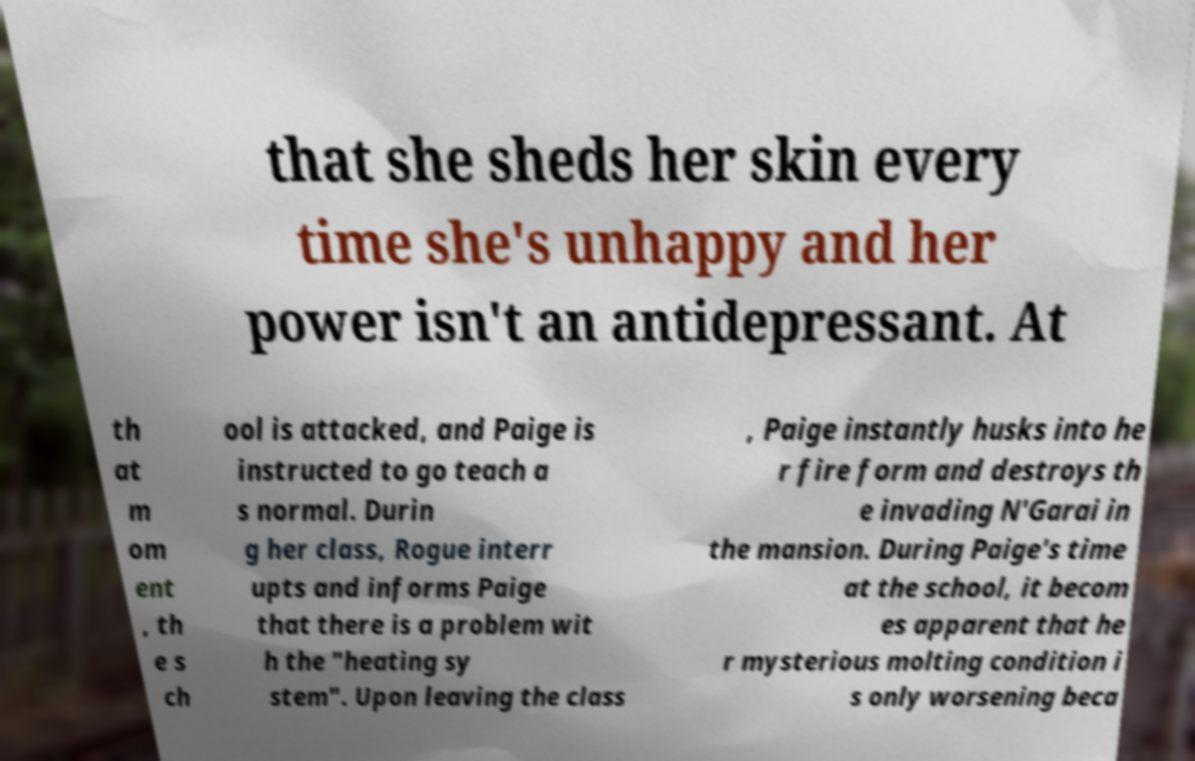Could you assist in decoding the text presented in this image and type it out clearly? that she sheds her skin every time she's unhappy and her power isn't an antidepressant. At th at m om ent , th e s ch ool is attacked, and Paige is instructed to go teach a s normal. Durin g her class, Rogue interr upts and informs Paige that there is a problem wit h the "heating sy stem". Upon leaving the class , Paige instantly husks into he r fire form and destroys th e invading N'Garai in the mansion. During Paige's time at the school, it becom es apparent that he r mysterious molting condition i s only worsening beca 